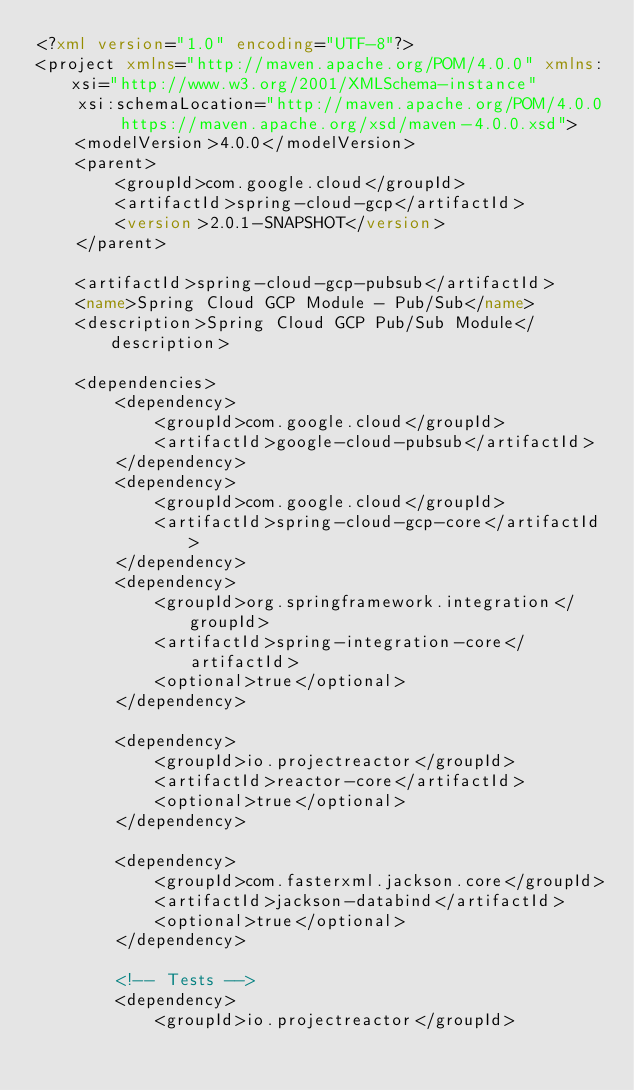Convert code to text. <code><loc_0><loc_0><loc_500><loc_500><_XML_><?xml version="1.0" encoding="UTF-8"?>
<project xmlns="http://maven.apache.org/POM/4.0.0" xmlns:xsi="http://www.w3.org/2001/XMLSchema-instance"
	xsi:schemaLocation="http://maven.apache.org/POM/4.0.0 https://maven.apache.org/xsd/maven-4.0.0.xsd">
	<modelVersion>4.0.0</modelVersion>
	<parent>
		<groupId>com.google.cloud</groupId>
		<artifactId>spring-cloud-gcp</artifactId>
		<version>2.0.1-SNAPSHOT</version>
	</parent>

	<artifactId>spring-cloud-gcp-pubsub</artifactId>
	<name>Spring Cloud GCP Module - Pub/Sub</name>
	<description>Spring Cloud GCP Pub/Sub Module</description>

	<dependencies>
		<dependency>
			<groupId>com.google.cloud</groupId>
			<artifactId>google-cloud-pubsub</artifactId>
		</dependency>
		<dependency>
			<groupId>com.google.cloud</groupId>
			<artifactId>spring-cloud-gcp-core</artifactId>
		</dependency>
		<dependency>
			<groupId>org.springframework.integration</groupId>
			<artifactId>spring-integration-core</artifactId>
			<optional>true</optional>
		</dependency>

		<dependency>
			<groupId>io.projectreactor</groupId>
			<artifactId>reactor-core</artifactId>
			<optional>true</optional>
		</dependency>

		<dependency>
			<groupId>com.fasterxml.jackson.core</groupId>
			<artifactId>jackson-databind</artifactId>
			<optional>true</optional>
		</dependency>

		<!-- Tests -->
		<dependency>
			<groupId>io.projectreactor</groupId></code> 